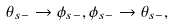Convert formula to latex. <formula><loc_0><loc_0><loc_500><loc_500>\theta _ { s - } \to \phi _ { s - } , \phi _ { s - } \to \theta _ { s - } ,</formula> 